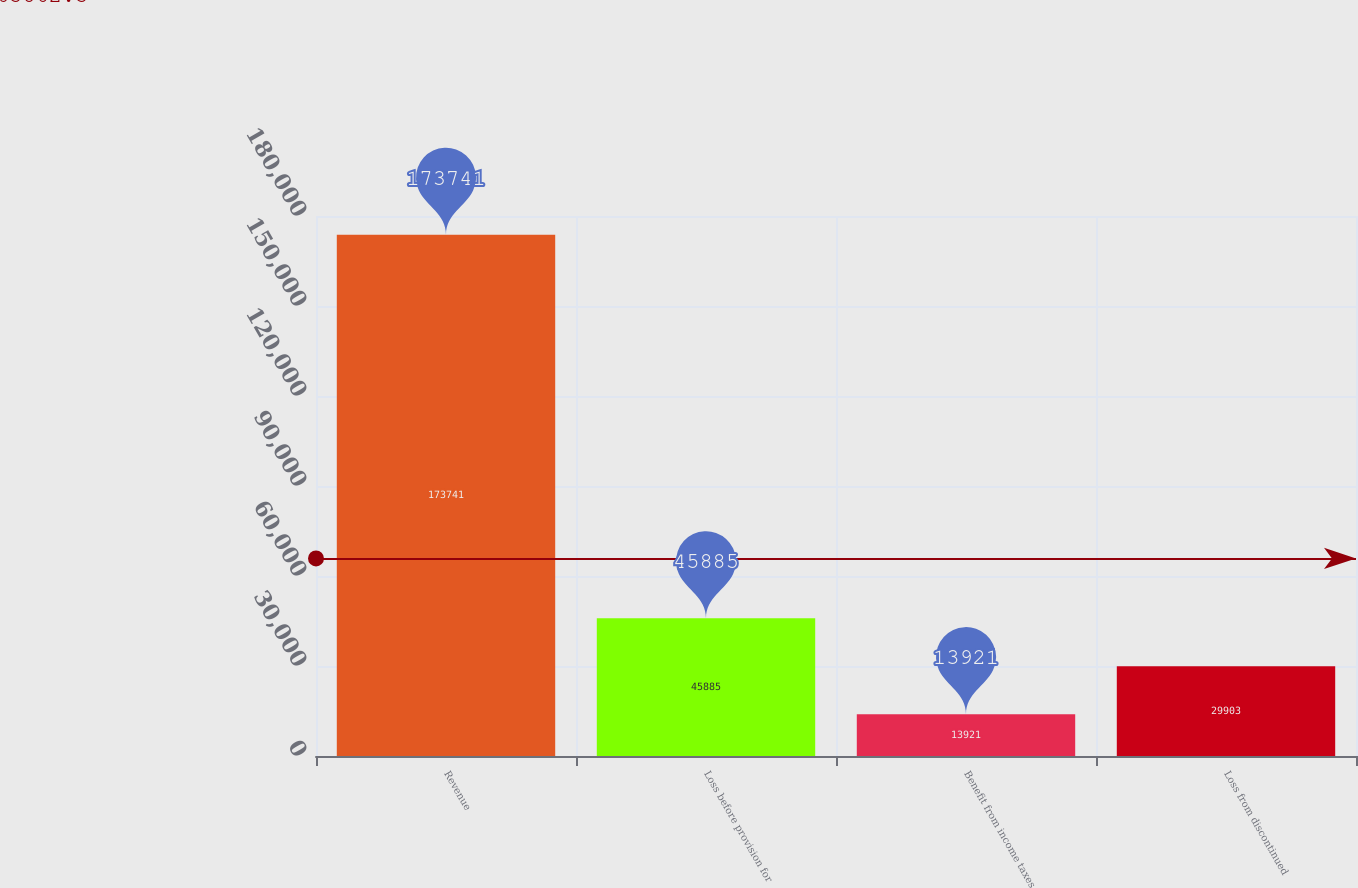<chart> <loc_0><loc_0><loc_500><loc_500><bar_chart><fcel>Revenue<fcel>Loss before provision for<fcel>Benefit from income taxes<fcel>Loss from discontinued<nl><fcel>173741<fcel>45885<fcel>13921<fcel>29903<nl></chart> 